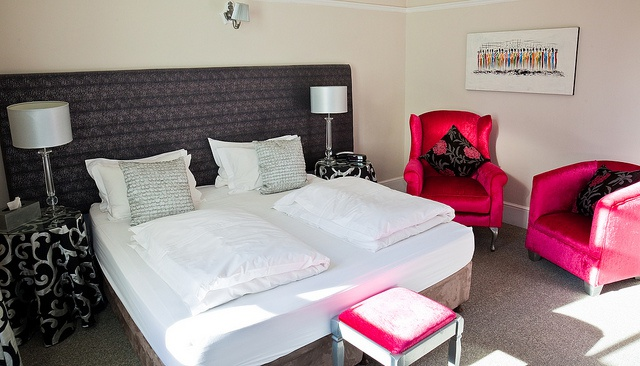Describe the objects in this image and their specific colors. I can see bed in gray, lightgray, and darkgray tones, chair in gray, brown, lightpink, and black tones, and chair in gray, brown, black, and maroon tones in this image. 